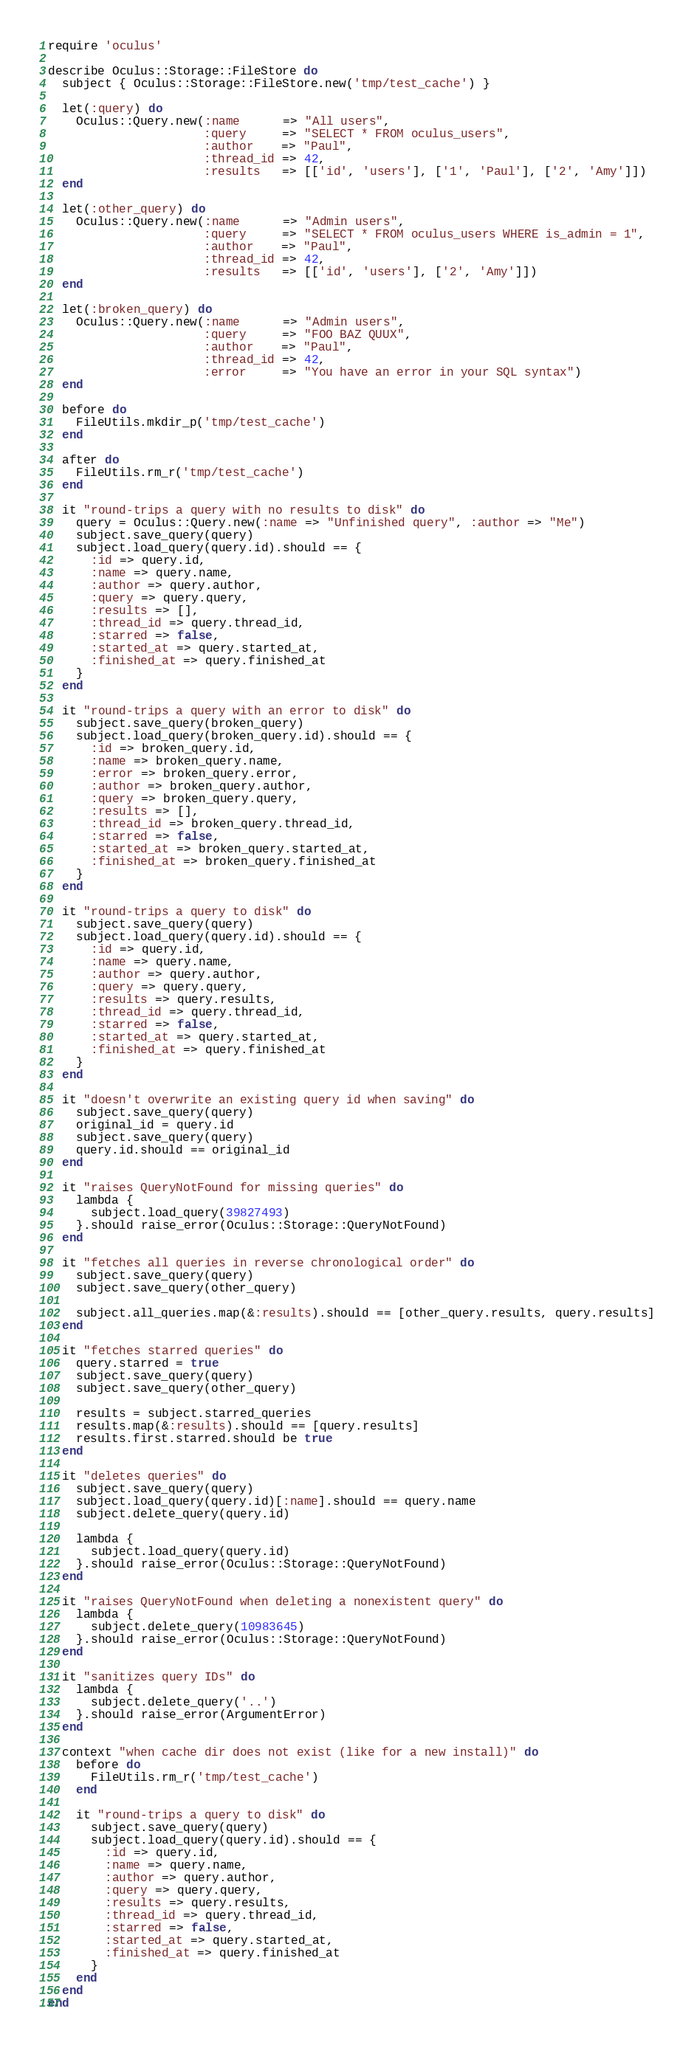Convert code to text. <code><loc_0><loc_0><loc_500><loc_500><_Ruby_>require 'oculus'

describe Oculus::Storage::FileStore do
  subject { Oculus::Storage::FileStore.new('tmp/test_cache') }

  let(:query) do
    Oculus::Query.new(:name      => "All users",
                      :query     => "SELECT * FROM oculus_users",
                      :author    => "Paul",
                      :thread_id => 42,
                      :results   => [['id', 'users'], ['1', 'Paul'], ['2', 'Amy']])
  end

  let(:other_query) do
    Oculus::Query.new(:name      => "Admin users",
                      :query     => "SELECT * FROM oculus_users WHERE is_admin = 1",
                      :author    => "Paul",
                      :thread_id => 42,
                      :results   => [['id', 'users'], ['2', 'Amy']])
  end

  let(:broken_query) do
    Oculus::Query.new(:name      => "Admin users",
                      :query     => "FOO BAZ QUUX",
                      :author    => "Paul",
                      :thread_id => 42,
                      :error     => "You have an error in your SQL syntax")
  end

  before do
    FileUtils.mkdir_p('tmp/test_cache')
  end

  after do
    FileUtils.rm_r('tmp/test_cache')
  end

  it "round-trips a query with no results to disk" do
    query = Oculus::Query.new(:name => "Unfinished query", :author => "Me")
    subject.save_query(query)
    subject.load_query(query.id).should == {
      :id => query.id,
      :name => query.name,
      :author => query.author,
      :query => query.query,
      :results => [],
      :thread_id => query.thread_id,
      :starred => false,
      :started_at => query.started_at,
      :finished_at => query.finished_at
    }
  end

  it "round-trips a query with an error to disk" do
    subject.save_query(broken_query)
    subject.load_query(broken_query.id).should == {
      :id => broken_query.id,
      :name => broken_query.name,
      :error => broken_query.error,
      :author => broken_query.author,
      :query => broken_query.query,
      :results => [],
      :thread_id => broken_query.thread_id,
      :starred => false,
      :started_at => broken_query.started_at,
      :finished_at => broken_query.finished_at
    }
  end

  it "round-trips a query to disk" do
    subject.save_query(query)
    subject.load_query(query.id).should == {
      :id => query.id,
      :name => query.name,
      :author => query.author,
      :query => query.query,
      :results => query.results,
      :thread_id => query.thread_id,
      :starred => false,
      :started_at => query.started_at,
      :finished_at => query.finished_at
    }
  end

  it "doesn't overwrite an existing query id when saving" do
    subject.save_query(query)
    original_id = query.id
    subject.save_query(query)
    query.id.should == original_id
  end

  it "raises QueryNotFound for missing queries" do
    lambda {
      subject.load_query(39827493)
    }.should raise_error(Oculus::Storage::QueryNotFound)
  end

  it "fetches all queries in reverse chronological order" do
    subject.save_query(query)
    subject.save_query(other_query)

    subject.all_queries.map(&:results).should == [other_query.results, query.results]
  end

  it "fetches starred queries" do
    query.starred = true
    subject.save_query(query)
    subject.save_query(other_query)

    results = subject.starred_queries
    results.map(&:results).should == [query.results]
    results.first.starred.should be true
  end

  it "deletes queries" do
    subject.save_query(query)
    subject.load_query(query.id)[:name].should == query.name
    subject.delete_query(query.id)

    lambda {
      subject.load_query(query.id)
    }.should raise_error(Oculus::Storage::QueryNotFound)
  end

  it "raises QueryNotFound when deleting a nonexistent query" do
    lambda {
      subject.delete_query(10983645)
    }.should raise_error(Oculus::Storage::QueryNotFound)
  end

  it "sanitizes query IDs" do
    lambda {
      subject.delete_query('..')
    }.should raise_error(ArgumentError)
  end

  context "when cache dir does not exist (like for a new install)" do
    before do
      FileUtils.rm_r('tmp/test_cache')
    end

    it "round-trips a query to disk" do
      subject.save_query(query)
      subject.load_query(query.id).should == {
        :id => query.id,
        :name => query.name,
        :author => query.author,
        :query => query.query,
        :results => query.results,
        :thread_id => query.thread_id,
        :starred => false,
        :started_at => query.started_at,
        :finished_at => query.finished_at
      }
    end
  end
end
</code> 